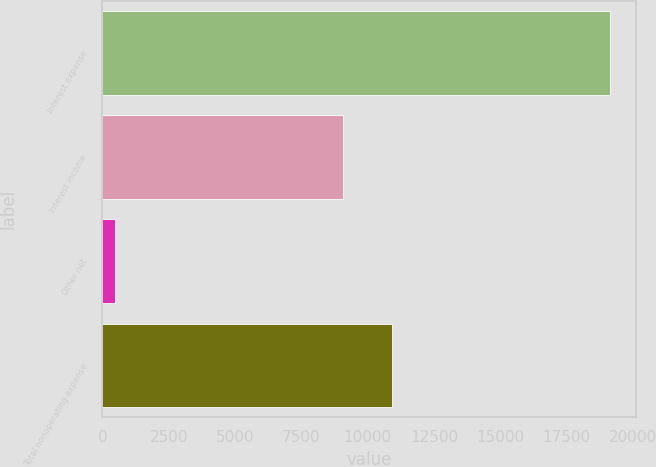Convert chart to OTSL. <chart><loc_0><loc_0><loc_500><loc_500><bar_chart><fcel>Interest expense<fcel>Interest income<fcel>Other net<fcel>Total nonoperating expense<nl><fcel>19146<fcel>9060<fcel>492<fcel>10925.4<nl></chart> 